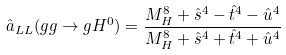Convert formula to latex. <formula><loc_0><loc_0><loc_500><loc_500>\hat { a } _ { L L } ( g g \rightarrow g H ^ { 0 } ) = \frac { M _ { H } ^ { 8 } + \hat { s } ^ { 4 } - \hat { t } ^ { 4 } - \hat { u } ^ { 4 } } { M _ { H } ^ { 8 } + \hat { s } ^ { 4 } + \hat { t } ^ { 4 } + \hat { u } ^ { 4 } }</formula> 